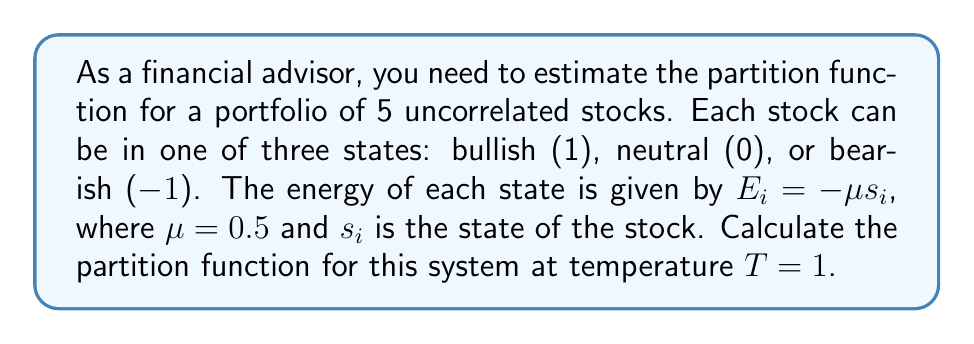Show me your answer to this math problem. 1. The partition function $Z$ is given by:
   $$Z = \sum_{\text{all states}} e^{-\beta E}$$
   where $\beta = \frac{1}{k_B T}$, and $k_B$ is set to 1 for simplicity.

2. For each stock, there are 3 possible states:
   - Bullish (1): $E_1 = -\mu (1) = -0.5$
   - Neutral (0): $E_0 = -\mu (0) = 0$
   - Bearish (-1): $E_{-1} = -\mu (-1) = 0.5$

3. The contribution to $Z$ from each stock is:
   $$z = e^{0.5} + 1 + e^{-0.5}$$

4. Since there are 5 uncorrelated stocks, the total partition function is:
   $$Z = z^5 = (e^{0.5} + 1 + e^{-0.5})^5$$

5. Calculate the numerical value:
   $$Z = (e^{0.5} + 1 + e^{-0.5})^5 \approx (2.6487)^5 \approx 130.6431$$
Answer: $Z \approx 130.6431$ 